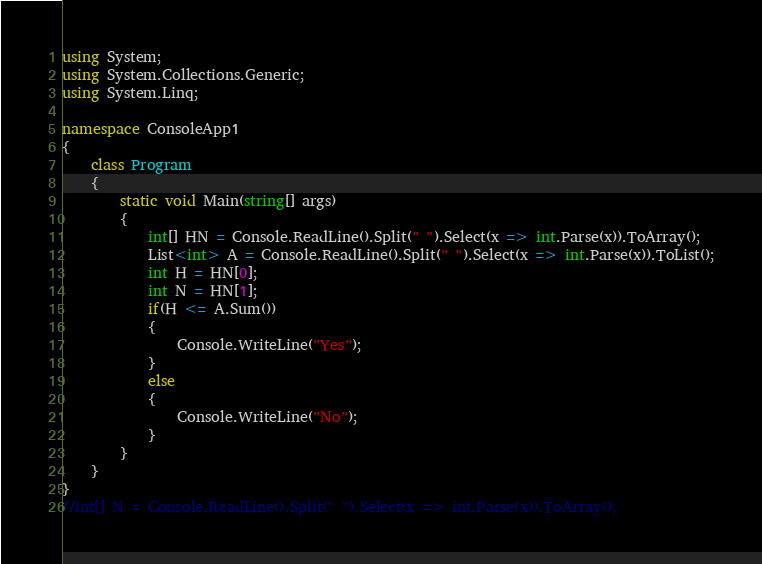<code> <loc_0><loc_0><loc_500><loc_500><_C#_>using System;
using System.Collections.Generic;
using System.Linq;

namespace ConsoleApp1
{
    class Program
    {
        static void Main(string[] args)
        {
            int[] HN = Console.ReadLine().Split(" ").Select(x => int.Parse(x)).ToArray();
            List<int> A = Console.ReadLine().Split(" ").Select(x => int.Parse(x)).ToList();
            int H = HN[0];
            int N = HN[1];
            if(H <= A.Sum())
            {
                Console.WriteLine("Yes");
            }
            else
            {
                Console.WriteLine("No");
            }
        }
    }
}
//int[] N = Console.ReadLine().Split(" ").Select(x => int.Parse(x)).ToArray();</code> 